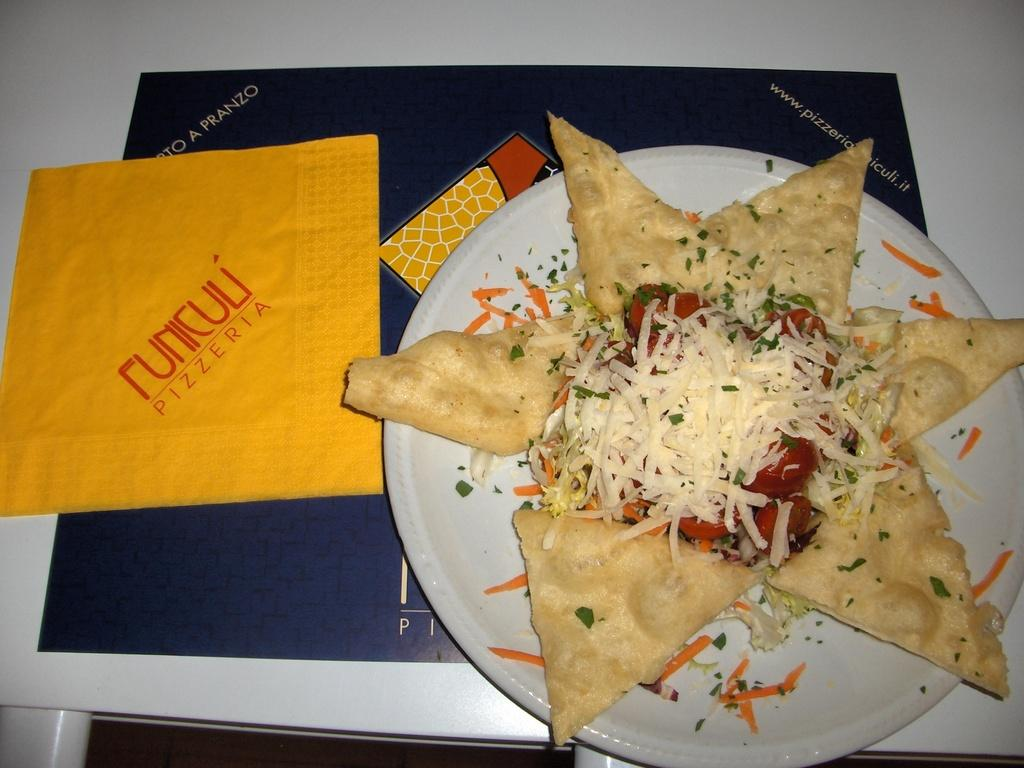<image>
Offer a succinct explanation of the picture presented. A dish of food sits next to a yellow pizzeria napkin. 